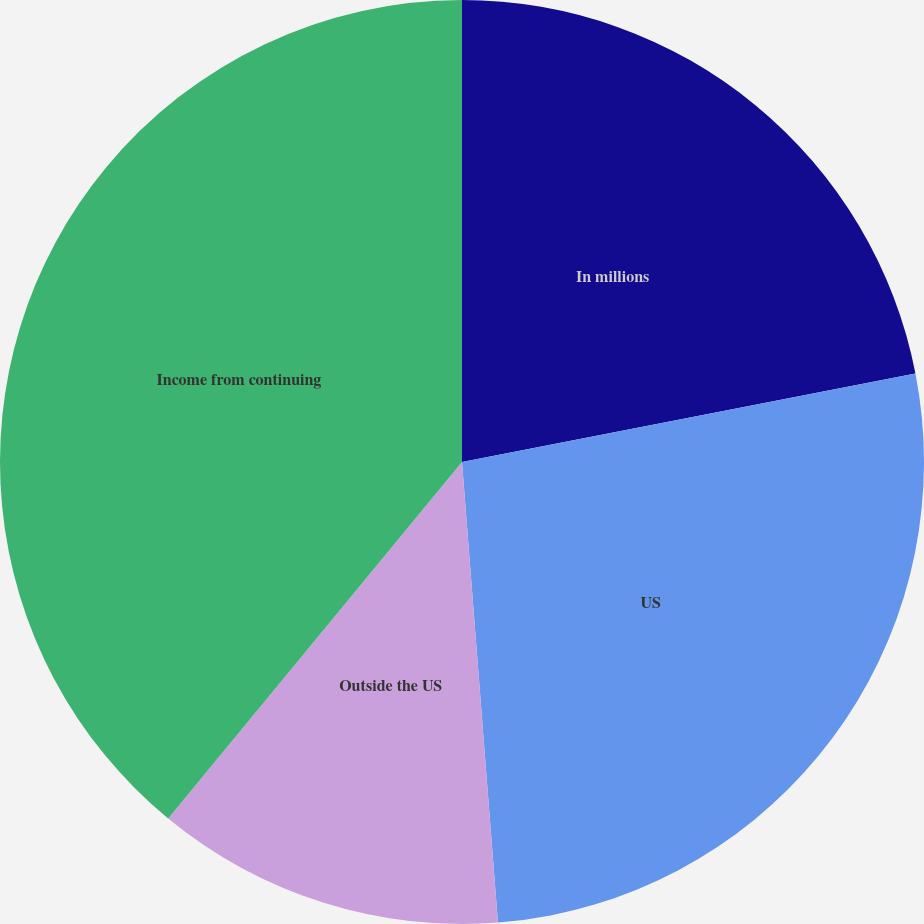Convert chart to OTSL. <chart><loc_0><loc_0><loc_500><loc_500><pie_chart><fcel>In millions<fcel>US<fcel>Outside the US<fcel>Income from continuing<nl><fcel>21.93%<fcel>26.83%<fcel>12.21%<fcel>39.03%<nl></chart> 